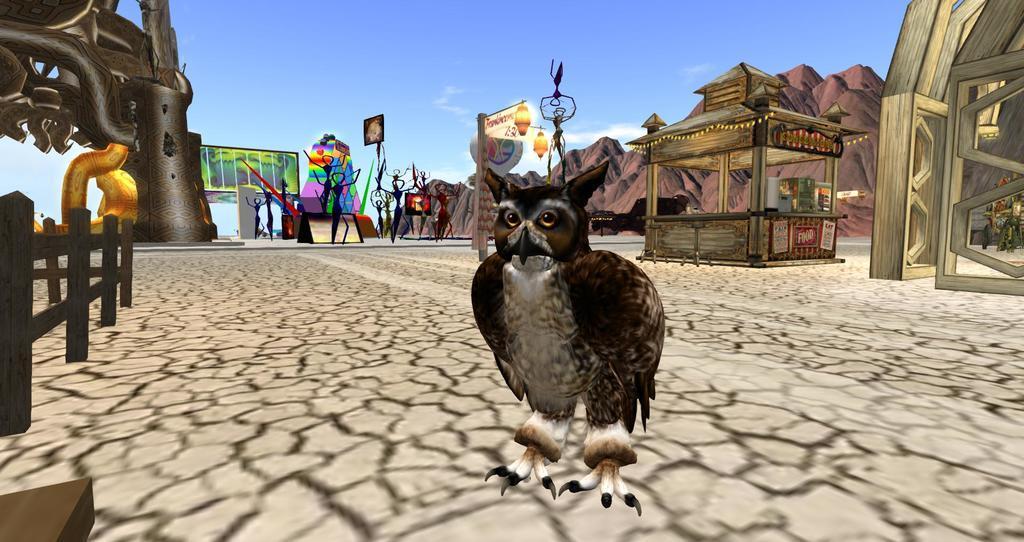Describe this image in one or two sentences. This is an animated image. In the image on the ground there is an owl standing. On the left side of the image there is a wooden fencing. Behind that there is an arch with design. And on the right side of the image there is an arch with door. Beside that there is a store with lights. In the background there are few images and also there is a pole with lamp and posters. Behind them there are hills. At the top of the image there is a sky. 